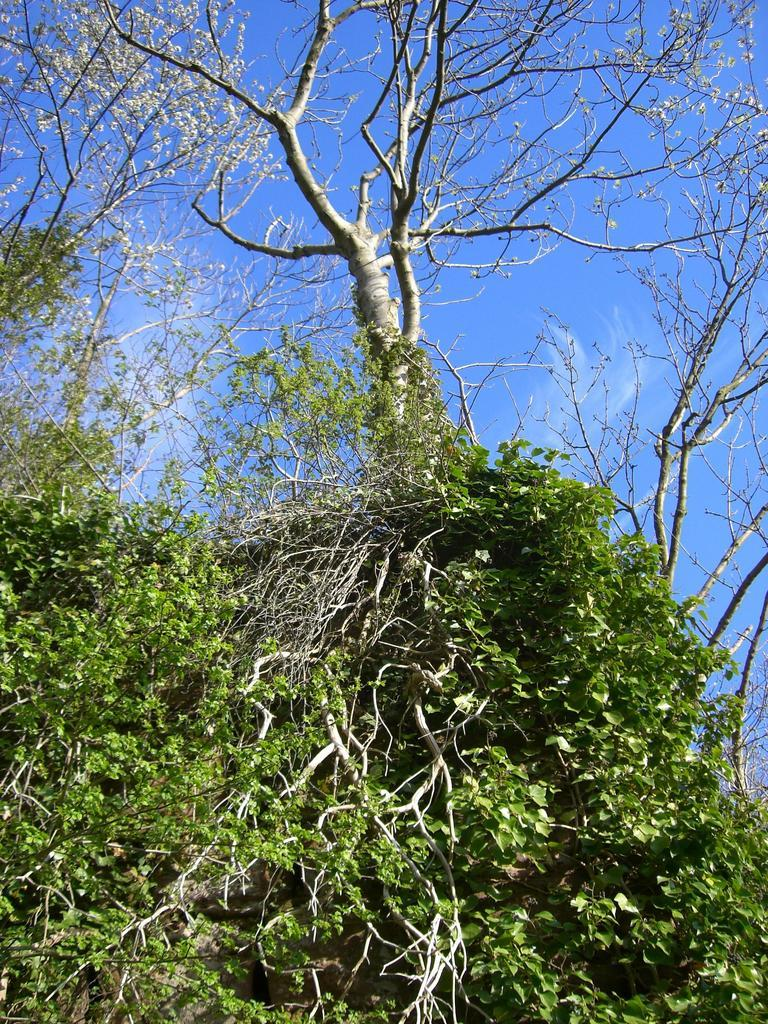What type of vegetation can be seen in the image? There are trees in the image. What color are the leaves on the trees? Green leaves are visible in the image. What is visible in the sky in the image? Clouds are present in the sky. What type of paste is being used to bake the cookies in the image? There is no oven or cookies present in the image, so it is not possible to determine if any paste is being used. 